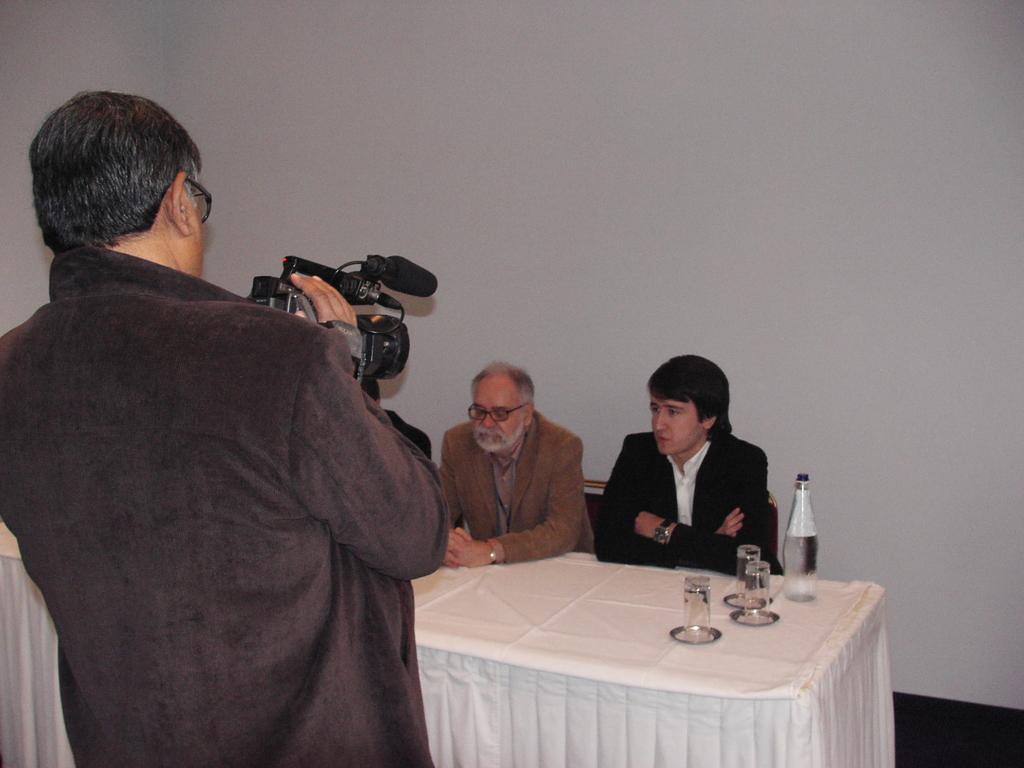Describe this image in one or two sentences. These two persons are sitting on the chairs,this person standing and holding camera. We can see glasses,bottle on the table. On the background we can see wall. 